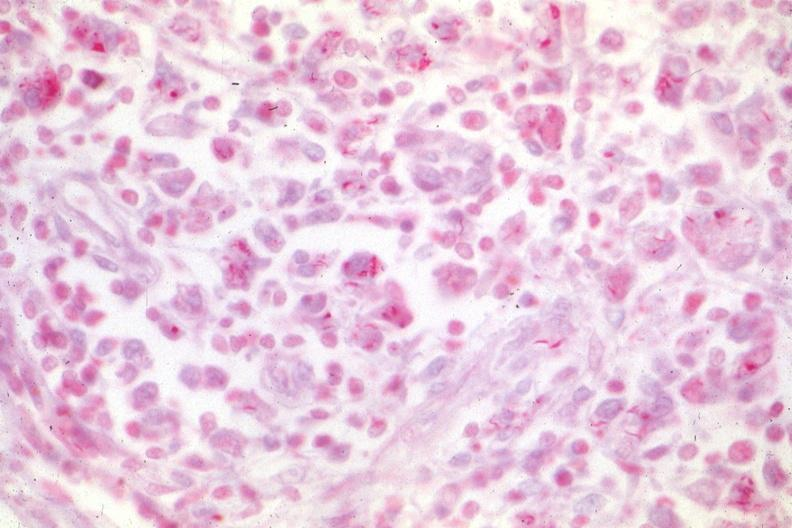s mycobacterium avium intracellulare present?
Answer the question using a single word or phrase. Yes 